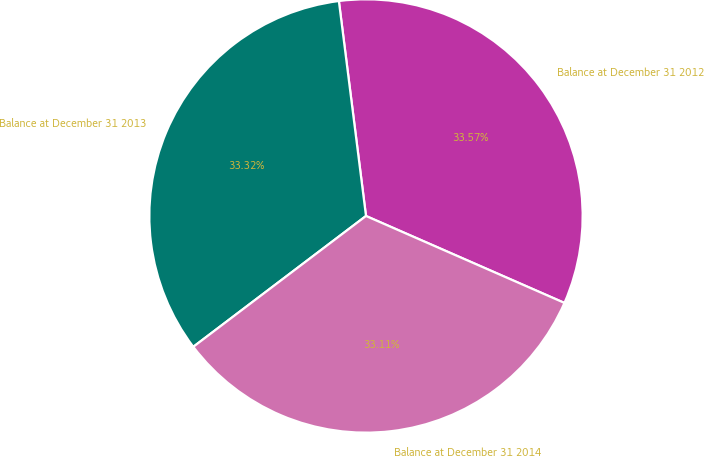<chart> <loc_0><loc_0><loc_500><loc_500><pie_chart><fcel>Balance at December 31 2012<fcel>Balance at December 31 2013<fcel>Balance at December 31 2014<nl><fcel>33.57%<fcel>33.32%<fcel>33.11%<nl></chart> 